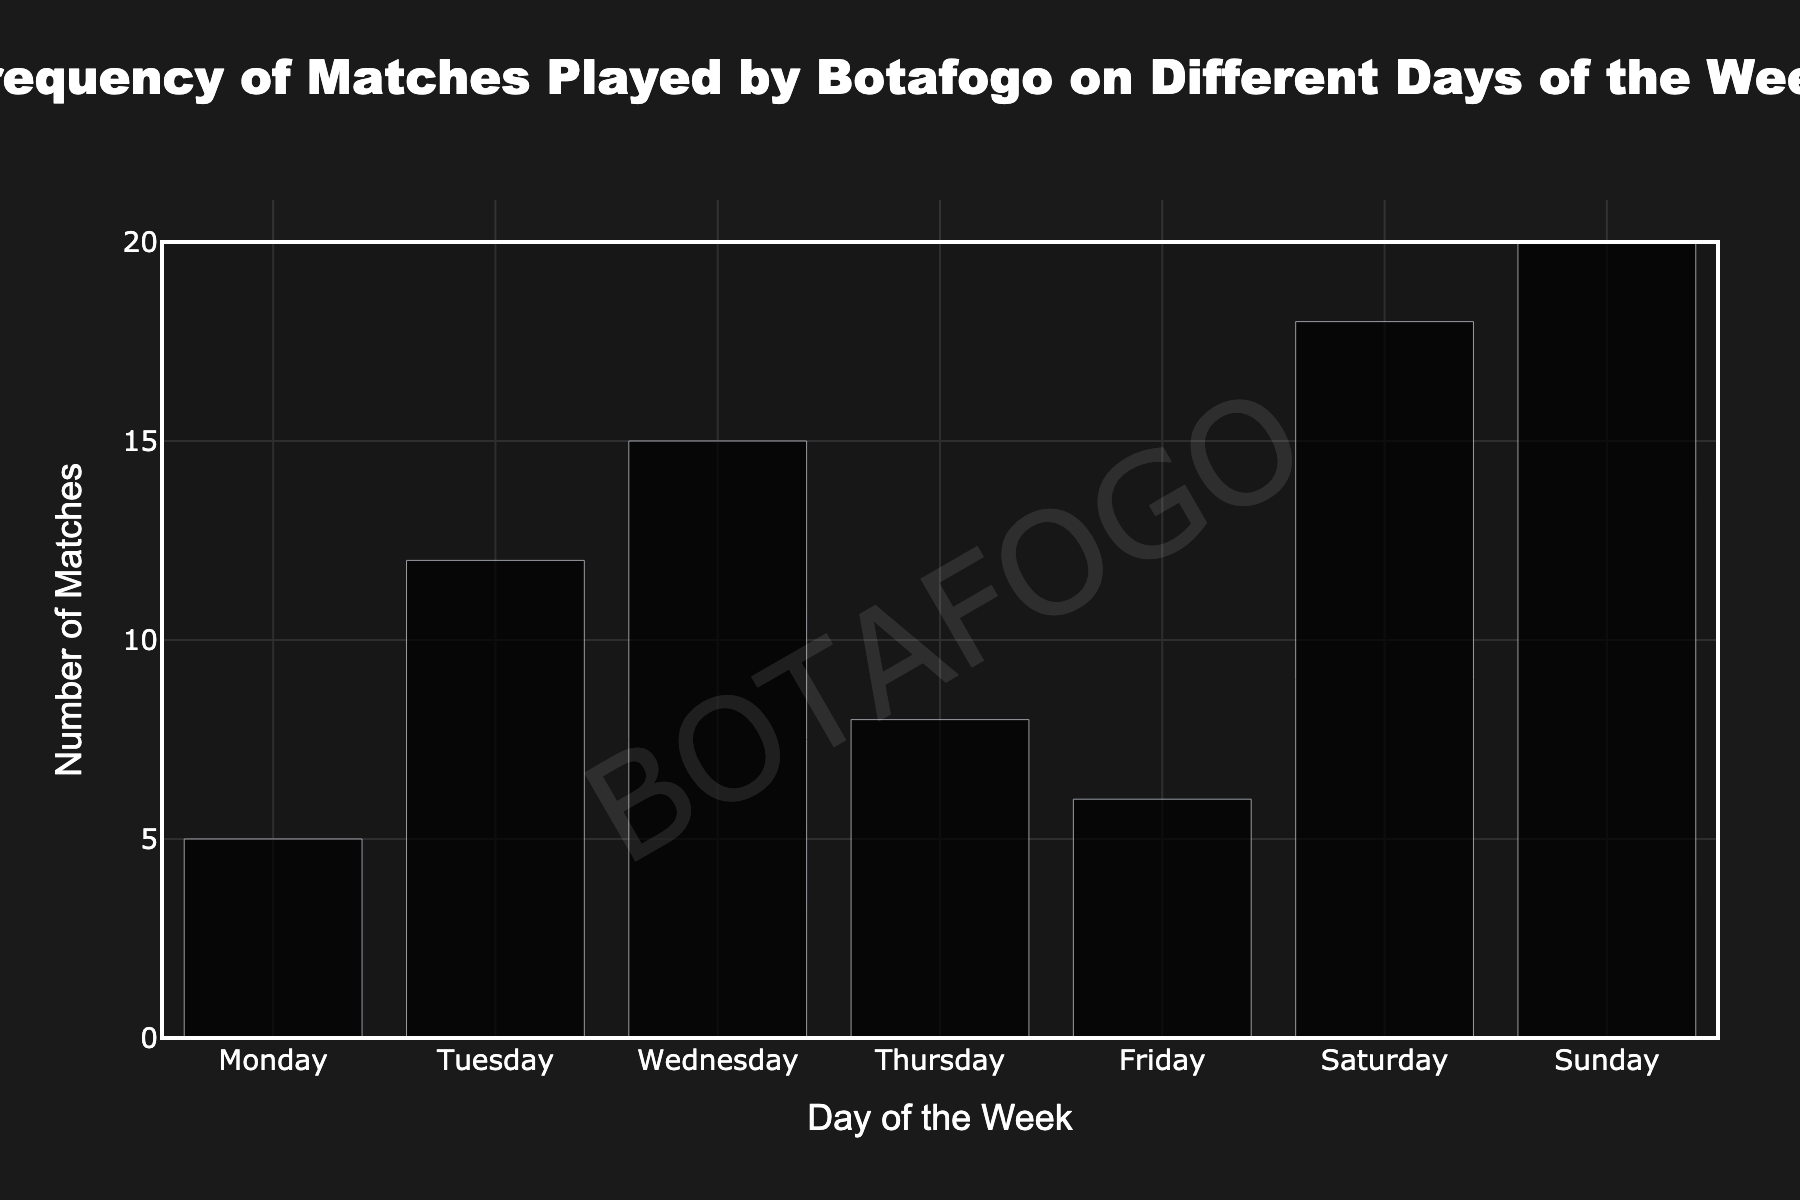What's the title of the chart? The title is typically found at the top of a figure and describes what the figure is about. In this case, it says "Frequency of Matches Played by Botafogo on Different Days of the Week."
Answer: Frequency of Matches Played by Botafogo on Different Days of the Week Which day of the week has the highest number of matches? Look for the bar that reaches the highest value on the y-axis. Here, the bar for "Sunday" is the tallest, indicating the highest number of matches.
Answer: Sunday Which day has the lowest frequency of matches played by Botafogo? Identify the shortest bar on the chart to find the day with the fewest matches. "Monday" has the shortest bar, indicating the lowest frequency.
Answer: Monday How many matches did Botafogo play on Saturday? Check the height of the bar corresponding to "Saturday" on the x-axis. Here, the value reaches 18 on the y-axis.
Answer: 18 What is the combined total of matches played on Tuesday and Wednesday? Add the frequencies of Tuesday and Wednesday. From the chart, Tuesday's frequency is 12 and Wednesday's is 15. Summing them up, 12 + 15 = 27.
Answer: 27 Which two consecutive days have the closest frequency of matches played? Compare the frequencies of each pair of consecutive days and find the pair with the smallest difference. Thursday (8) and Friday (6) differ by only 2 matches.
Answer: Thursday and Friday Are there any days where Botafogo played more than 15 matches? If so, which ones? Look for bars that extend above the 15-mark on the y-axis. Both "Wednesday" (15) and "Saturday" (18) meet this criterion, but "Wednesday" equals rather than exceeds it, so only "Saturday" and "Sunday" (20) qualify.
Answer: Saturday, Sunday What is the average frequency of matches played across all days? Add the frequencies for all days and divide by the number of days. The sum is 5 + 12 + 15 + 8 + 6 + 18 + 20 = 84. There are 7 days, so the average is 84 / 7 = 12.
Answer: 12 How many total matches did Botafogo play throughout the entire week? Sum the frequencies of matches played on each day of the week. The total is 5 (Monday) + 12 (Tuesday) + 15 (Wednesday) + 8 (Thursday) + 6 (Friday) + 18 (Saturday) + 20 (Sunday) = 84 matches.
Answer: 84 What is the difference in the number of matches played between the day with the maximum frequency and the day with the minimum frequency? The maximum frequency is 20 (Sunday) and the minimum is 5 (Monday). The difference is 20 - 5 = 15.
Answer: 15 